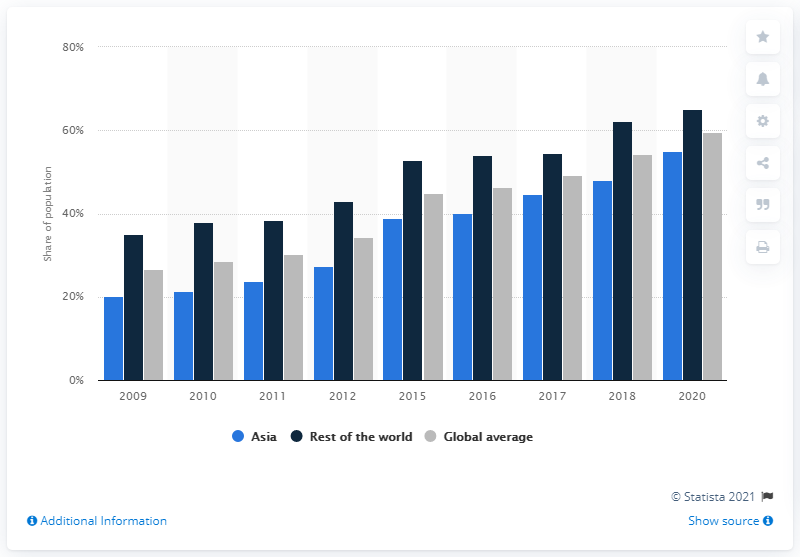Outline some significant characteristics in this image. In 2020, the global average internet penetration rate was 59.6%. 